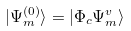<formula> <loc_0><loc_0><loc_500><loc_500>| \Psi _ { m } ^ { ( 0 ) } \rangle = | \Phi _ { c } \Psi _ { m } ^ { v } \rangle</formula> 